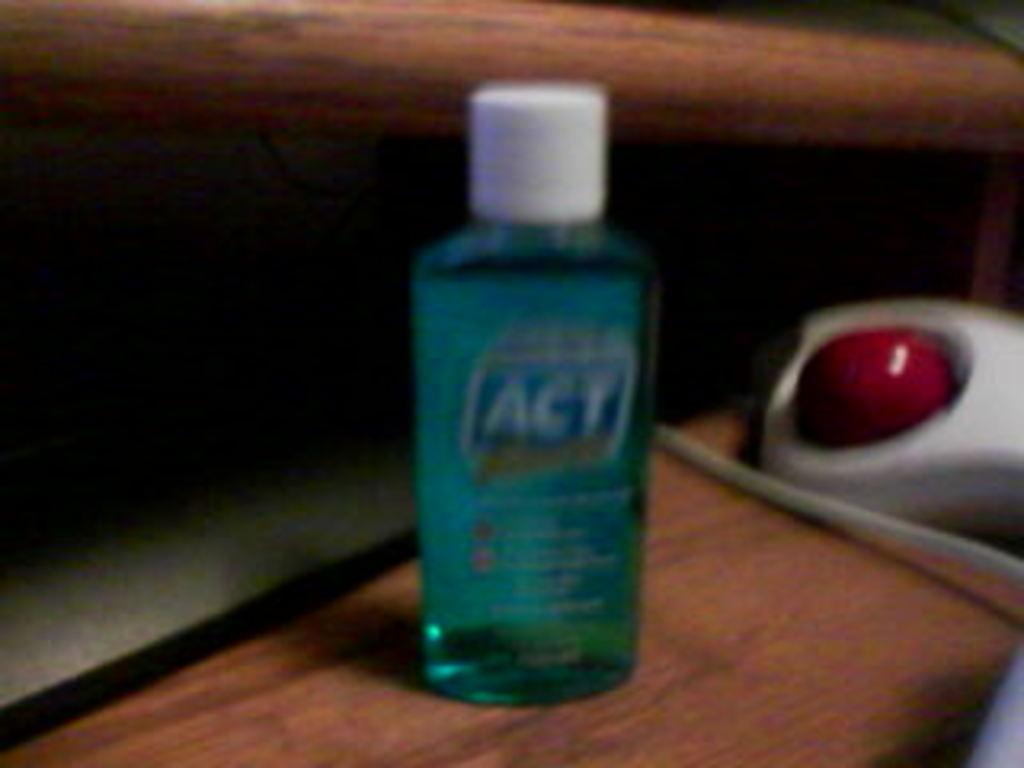What name on the bottle it starts with an a?
Keep it short and to the point. Act. 